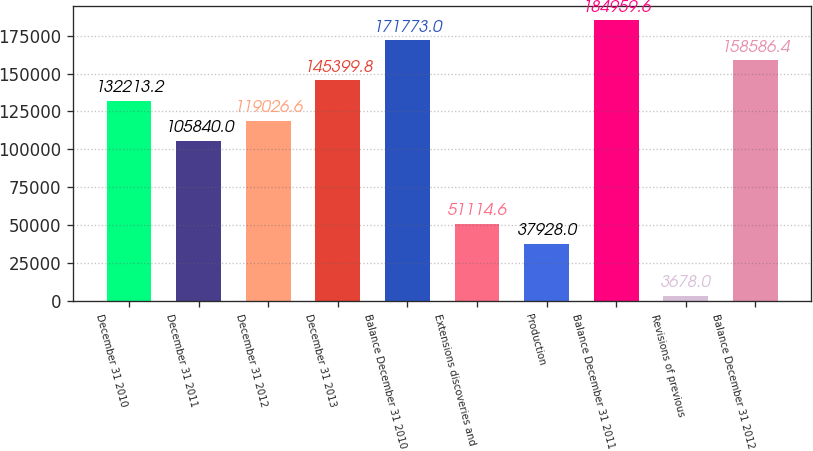Convert chart to OTSL. <chart><loc_0><loc_0><loc_500><loc_500><bar_chart><fcel>December 31 2010<fcel>December 31 2011<fcel>December 31 2012<fcel>December 31 2013<fcel>Balance December 31 2010<fcel>Extensions discoveries and<fcel>Production<fcel>Balance December 31 2011<fcel>Revisions of previous<fcel>Balance December 31 2012<nl><fcel>132213<fcel>105840<fcel>119027<fcel>145400<fcel>171773<fcel>51114.6<fcel>37928<fcel>184960<fcel>3678<fcel>158586<nl></chart> 